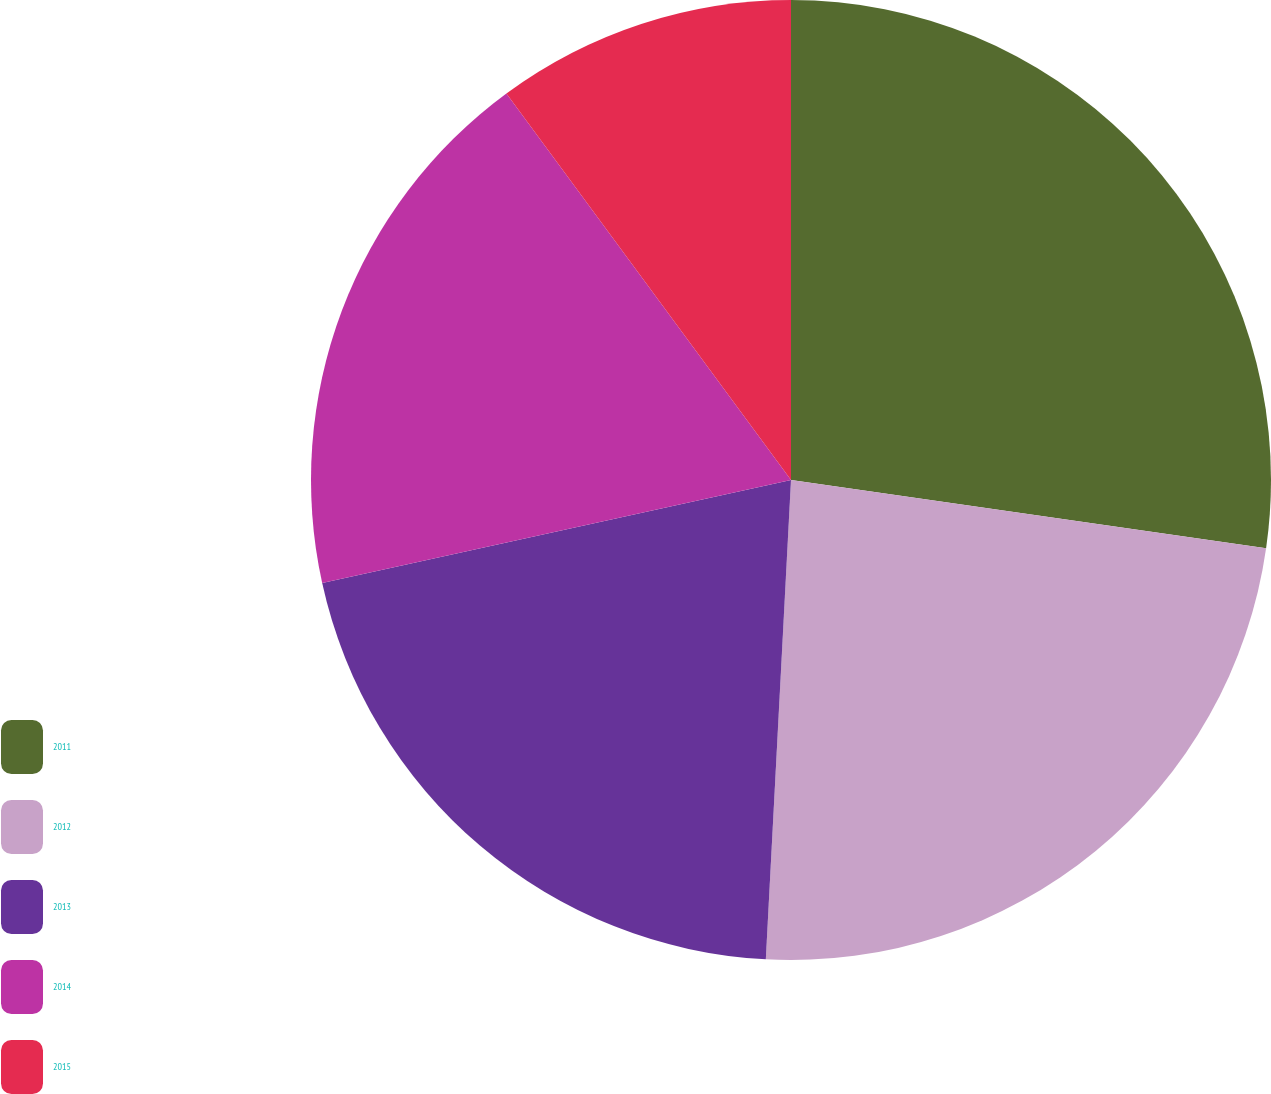Convert chart to OTSL. <chart><loc_0><loc_0><loc_500><loc_500><pie_chart><fcel>2011<fcel>2012<fcel>2013<fcel>2014<fcel>2015<nl><fcel>27.27%<fcel>23.56%<fcel>20.72%<fcel>18.34%<fcel>10.1%<nl></chart> 